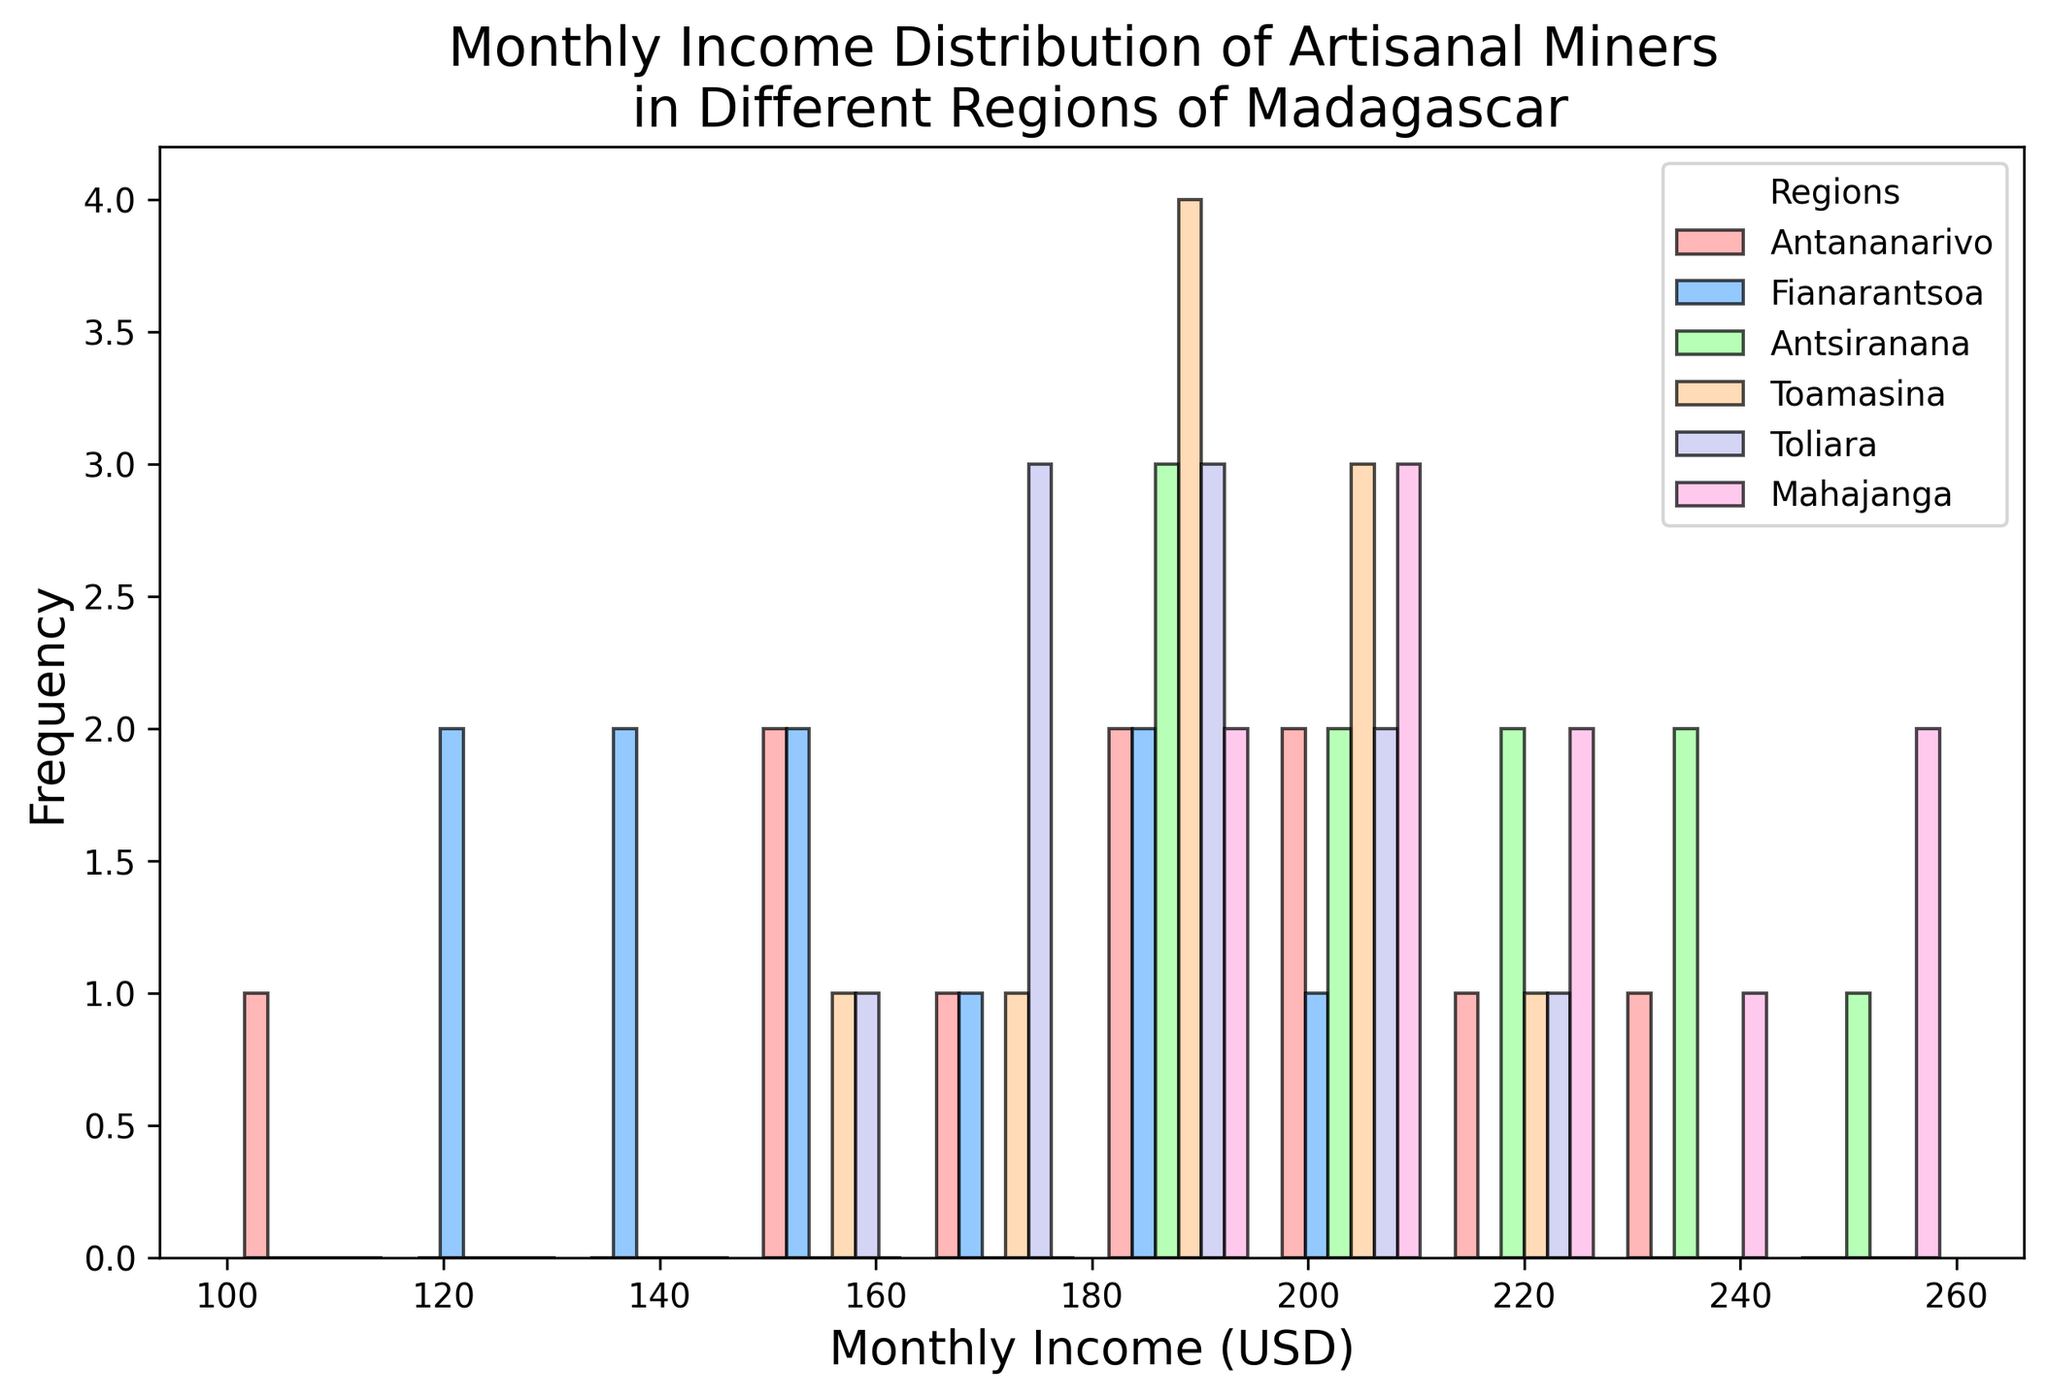What is the range of the monthly income for artisanal miners in Antananarivo? To find the range, identify the minimum and maximum values for monthly income in Antananarivo from the histogram. The minimum is 100 USD and the maximum is 230 USD. The range is 230 - 100 = 130 USD.
Answer: 130 USD Which region has the highest frequency of income in the 200-220 USD range? Look at the bars between the 200-220 USD range in the histogram and compare their heights across different regions. Regions represented by higher bars have a higher frequency.
Answer: Antsiranana How does the income distribution in Antananarivo compare to that in Fianarantsoa? Compare the general shape and spread of the histogram bars for Antananarivo and Fianarantsoa. Antananarivo has a wider spread with incomes ranging from 100 to 230 USD, while Fianarantsoa's spread is from 120 to 200 USD. The distribution in Antananarivo is more varied while Fianarantsoa's is more concentrated.
Answer: More varied in Antananarivo What is the median monthly income for miners in Toliara? To find the median, locate the middle income value when sorted. For Toliara, arranging the incomes: 155, 165, 170, 175, 180, 180, 185, 200, 210, 220. The middle values are 180 and 180, hence the median is (180 + 180) / 2 = 180 USD.
Answer: 180 USD Which region has the most uniform income distribution? Observe the histogram to see which region has bars of relatively similar height across different income ranges.
Answer: Toliara How many income bins show a higher frequency for Mahajanga compared to Toamasina? Compare each income bin of Mahajanga and Toamasina in the histogram. Count the number of bins where Mahajanga's bars are higher. Mahajanga has higher bars in 4 bins compared to Toamasina.
Answer: 4 What is the most common monthly income range for miners in Toamasina? Locate the bin with the tallest bar for Toamasina in the histogram. The highest bar in Toamasina falls between the 180-190 USD range.
Answer: 180-190 USD Are there any regions with no miners earning in the 100-120 USD range? Check each region's bars in the 100-120 USD range. If there's no bar for a region, it means no miners earn in that range.
Answer: All except Antananarivo and Fianarantsoa 